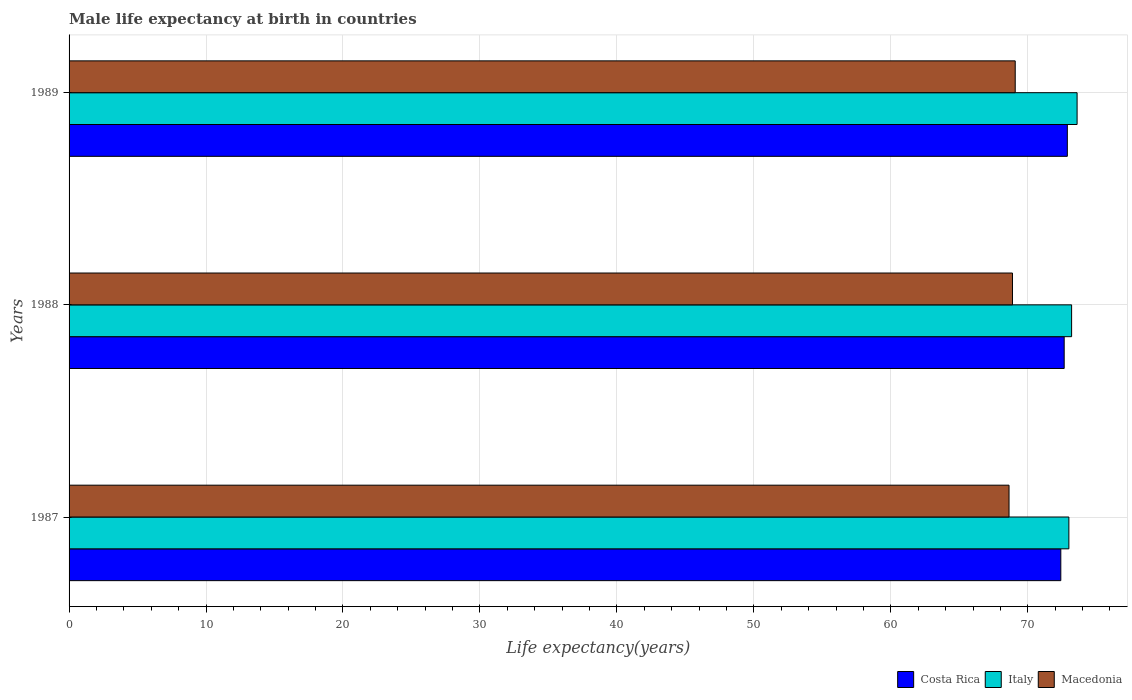How many different coloured bars are there?
Provide a succinct answer. 3. Are the number of bars per tick equal to the number of legend labels?
Your response must be concise. Yes. How many bars are there on the 1st tick from the bottom?
Your answer should be compact. 3. In how many cases, is the number of bars for a given year not equal to the number of legend labels?
Ensure brevity in your answer.  0. What is the male life expectancy at birth in Italy in 1987?
Your answer should be compact. 73. Across all years, what is the maximum male life expectancy at birth in Costa Rica?
Your answer should be compact. 72.89. Across all years, what is the minimum male life expectancy at birth in Costa Rica?
Ensure brevity in your answer.  72.41. What is the total male life expectancy at birth in Costa Rica in the graph?
Ensure brevity in your answer.  217.96. What is the difference between the male life expectancy at birth in Costa Rica in 1987 and that in 1988?
Ensure brevity in your answer.  -0.25. What is the difference between the male life expectancy at birth in Italy in 1987 and the male life expectancy at birth in Macedonia in 1988?
Your answer should be compact. 4.12. What is the average male life expectancy at birth in Italy per year?
Offer a very short reply. 73.27. In the year 1988, what is the difference between the male life expectancy at birth in Costa Rica and male life expectancy at birth in Italy?
Make the answer very short. -0.54. What is the ratio of the male life expectancy at birth in Costa Rica in 1988 to that in 1989?
Give a very brief answer. 1. Is the difference between the male life expectancy at birth in Costa Rica in 1987 and 1989 greater than the difference between the male life expectancy at birth in Italy in 1987 and 1989?
Provide a succinct answer. Yes. What is the difference between the highest and the second highest male life expectancy at birth in Costa Rica?
Make the answer very short. 0.23. What is the difference between the highest and the lowest male life expectancy at birth in Italy?
Give a very brief answer. 0.6. In how many years, is the male life expectancy at birth in Macedonia greater than the average male life expectancy at birth in Macedonia taken over all years?
Provide a short and direct response. 2. Is the sum of the male life expectancy at birth in Costa Rica in 1988 and 1989 greater than the maximum male life expectancy at birth in Italy across all years?
Provide a succinct answer. Yes. What does the 1st bar from the top in 1988 represents?
Your response must be concise. Macedonia. What does the 1st bar from the bottom in 1988 represents?
Your answer should be very brief. Costa Rica. Is it the case that in every year, the sum of the male life expectancy at birth in Italy and male life expectancy at birth in Costa Rica is greater than the male life expectancy at birth in Macedonia?
Ensure brevity in your answer.  Yes. Are all the bars in the graph horizontal?
Offer a very short reply. Yes. What is the difference between two consecutive major ticks on the X-axis?
Offer a terse response. 10. How many legend labels are there?
Your answer should be very brief. 3. What is the title of the graph?
Offer a very short reply. Male life expectancy at birth in countries. Does "Korea (Republic)" appear as one of the legend labels in the graph?
Ensure brevity in your answer.  No. What is the label or title of the X-axis?
Offer a terse response. Life expectancy(years). What is the label or title of the Y-axis?
Provide a short and direct response. Years. What is the Life expectancy(years) in Costa Rica in 1987?
Make the answer very short. 72.41. What is the Life expectancy(years) of Italy in 1987?
Provide a short and direct response. 73. What is the Life expectancy(years) in Macedonia in 1987?
Make the answer very short. 68.63. What is the Life expectancy(years) of Costa Rica in 1988?
Ensure brevity in your answer.  72.66. What is the Life expectancy(years) of Italy in 1988?
Give a very brief answer. 73.2. What is the Life expectancy(years) of Macedonia in 1988?
Your answer should be compact. 68.88. What is the Life expectancy(years) in Costa Rica in 1989?
Your response must be concise. 72.89. What is the Life expectancy(years) of Italy in 1989?
Offer a terse response. 73.6. What is the Life expectancy(years) in Macedonia in 1989?
Your answer should be compact. 69.08. Across all years, what is the maximum Life expectancy(years) of Costa Rica?
Keep it short and to the point. 72.89. Across all years, what is the maximum Life expectancy(years) of Italy?
Offer a terse response. 73.6. Across all years, what is the maximum Life expectancy(years) in Macedonia?
Your answer should be very brief. 69.08. Across all years, what is the minimum Life expectancy(years) in Costa Rica?
Your response must be concise. 72.41. Across all years, what is the minimum Life expectancy(years) of Italy?
Ensure brevity in your answer.  73. Across all years, what is the minimum Life expectancy(years) of Macedonia?
Your answer should be compact. 68.63. What is the total Life expectancy(years) in Costa Rica in the graph?
Provide a short and direct response. 217.96. What is the total Life expectancy(years) in Italy in the graph?
Provide a short and direct response. 219.8. What is the total Life expectancy(years) in Macedonia in the graph?
Offer a very short reply. 206.6. What is the difference between the Life expectancy(years) of Costa Rica in 1987 and that in 1988?
Make the answer very short. -0.25. What is the difference between the Life expectancy(years) of Macedonia in 1987 and that in 1988?
Provide a short and direct response. -0.25. What is the difference between the Life expectancy(years) in Costa Rica in 1987 and that in 1989?
Keep it short and to the point. -0.48. What is the difference between the Life expectancy(years) in Italy in 1987 and that in 1989?
Keep it short and to the point. -0.6. What is the difference between the Life expectancy(years) of Macedonia in 1987 and that in 1989?
Your response must be concise. -0.45. What is the difference between the Life expectancy(years) of Costa Rica in 1988 and that in 1989?
Ensure brevity in your answer.  -0.23. What is the difference between the Life expectancy(years) in Macedonia in 1988 and that in 1989?
Your answer should be very brief. -0.2. What is the difference between the Life expectancy(years) in Costa Rica in 1987 and the Life expectancy(years) in Italy in 1988?
Your response must be concise. -0.79. What is the difference between the Life expectancy(years) in Costa Rica in 1987 and the Life expectancy(years) in Macedonia in 1988?
Offer a terse response. 3.53. What is the difference between the Life expectancy(years) in Italy in 1987 and the Life expectancy(years) in Macedonia in 1988?
Your answer should be very brief. 4.12. What is the difference between the Life expectancy(years) of Costa Rica in 1987 and the Life expectancy(years) of Italy in 1989?
Make the answer very short. -1.19. What is the difference between the Life expectancy(years) of Costa Rica in 1987 and the Life expectancy(years) of Macedonia in 1989?
Your response must be concise. 3.33. What is the difference between the Life expectancy(years) in Italy in 1987 and the Life expectancy(years) in Macedonia in 1989?
Provide a short and direct response. 3.92. What is the difference between the Life expectancy(years) in Costa Rica in 1988 and the Life expectancy(years) in Italy in 1989?
Your answer should be very brief. -0.94. What is the difference between the Life expectancy(years) of Costa Rica in 1988 and the Life expectancy(years) of Macedonia in 1989?
Make the answer very short. 3.58. What is the difference between the Life expectancy(years) in Italy in 1988 and the Life expectancy(years) in Macedonia in 1989?
Ensure brevity in your answer.  4.12. What is the average Life expectancy(years) of Costa Rica per year?
Offer a very short reply. 72.65. What is the average Life expectancy(years) of Italy per year?
Provide a short and direct response. 73.27. What is the average Life expectancy(years) in Macedonia per year?
Make the answer very short. 68.87. In the year 1987, what is the difference between the Life expectancy(years) of Costa Rica and Life expectancy(years) of Italy?
Keep it short and to the point. -0.59. In the year 1987, what is the difference between the Life expectancy(years) of Costa Rica and Life expectancy(years) of Macedonia?
Keep it short and to the point. 3.78. In the year 1987, what is the difference between the Life expectancy(years) in Italy and Life expectancy(years) in Macedonia?
Your response must be concise. 4.37. In the year 1988, what is the difference between the Life expectancy(years) in Costa Rica and Life expectancy(years) in Italy?
Your answer should be compact. -0.54. In the year 1988, what is the difference between the Life expectancy(years) in Costa Rica and Life expectancy(years) in Macedonia?
Offer a terse response. 3.77. In the year 1988, what is the difference between the Life expectancy(years) of Italy and Life expectancy(years) of Macedonia?
Offer a terse response. 4.32. In the year 1989, what is the difference between the Life expectancy(years) of Costa Rica and Life expectancy(years) of Italy?
Give a very brief answer. -0.71. In the year 1989, what is the difference between the Life expectancy(years) in Costa Rica and Life expectancy(years) in Macedonia?
Provide a succinct answer. 3.81. In the year 1989, what is the difference between the Life expectancy(years) of Italy and Life expectancy(years) of Macedonia?
Your answer should be compact. 4.52. What is the ratio of the Life expectancy(years) in Italy in 1987 to that in 1988?
Offer a very short reply. 1. What is the ratio of the Life expectancy(years) of Macedonia in 1987 to that in 1988?
Make the answer very short. 1. What is the ratio of the Life expectancy(years) in Costa Rica in 1987 to that in 1989?
Provide a succinct answer. 0.99. What is the ratio of the Life expectancy(years) of Macedonia in 1987 to that in 1989?
Your answer should be very brief. 0.99. What is the ratio of the Life expectancy(years) in Costa Rica in 1988 to that in 1989?
Your answer should be very brief. 1. What is the ratio of the Life expectancy(years) of Italy in 1988 to that in 1989?
Make the answer very short. 0.99. What is the difference between the highest and the second highest Life expectancy(years) in Costa Rica?
Your answer should be very brief. 0.23. What is the difference between the highest and the second highest Life expectancy(years) in Italy?
Your response must be concise. 0.4. What is the difference between the highest and the second highest Life expectancy(years) of Macedonia?
Your response must be concise. 0.2. What is the difference between the highest and the lowest Life expectancy(years) of Costa Rica?
Your answer should be very brief. 0.48. What is the difference between the highest and the lowest Life expectancy(years) of Macedonia?
Give a very brief answer. 0.45. 